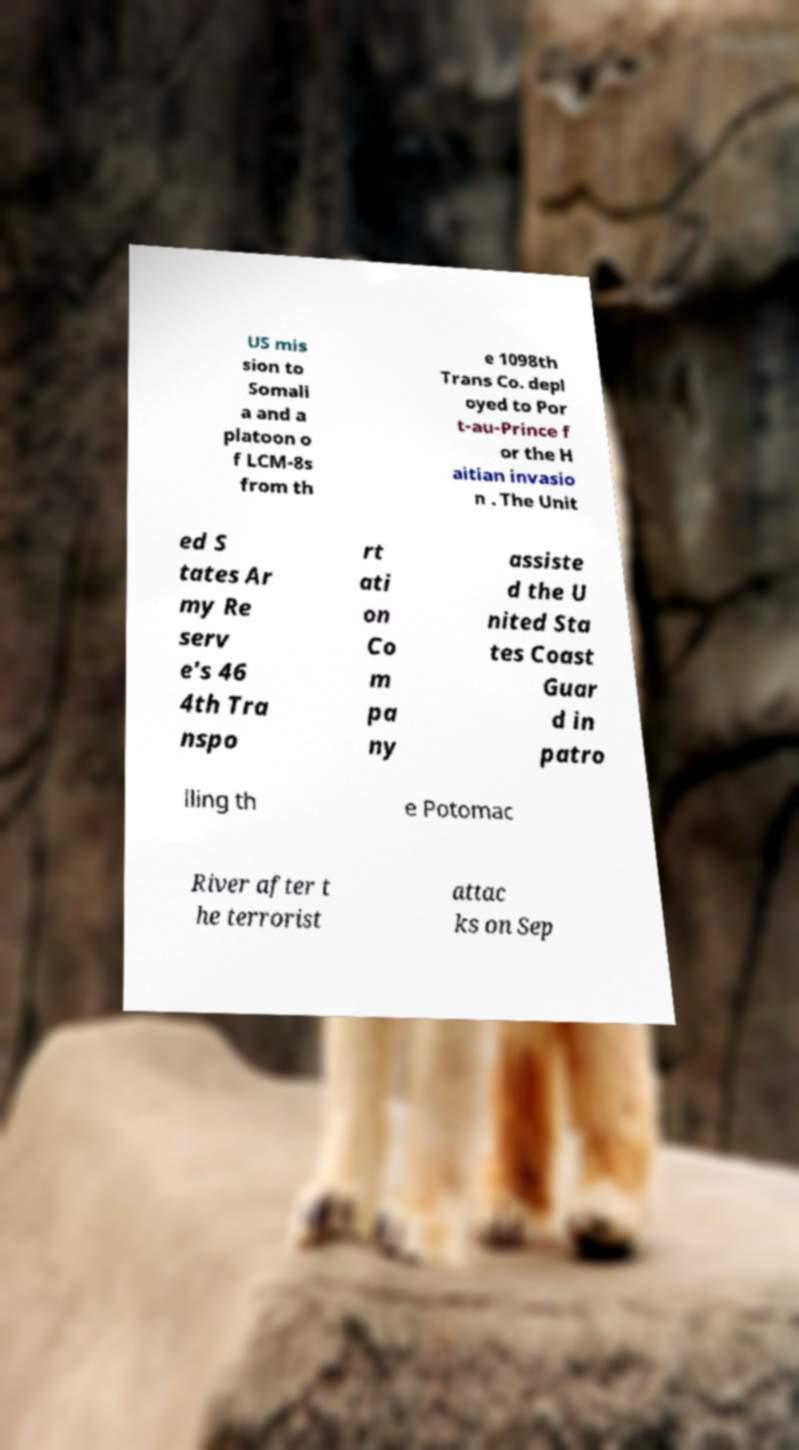Can you read and provide the text displayed in the image?This photo seems to have some interesting text. Can you extract and type it out for me? US mis sion to Somali a and a platoon o f LCM-8s from th e 1098th Trans Co. depl oyed to Por t-au-Prince f or the H aitian invasio n . The Unit ed S tates Ar my Re serv e's 46 4th Tra nspo rt ati on Co m pa ny assiste d the U nited Sta tes Coast Guar d in patro lling th e Potomac River after t he terrorist attac ks on Sep 